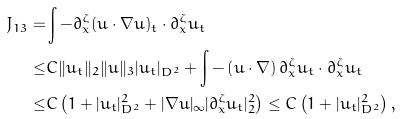Convert formula to latex. <formula><loc_0><loc_0><loc_500><loc_500>J _ { 1 3 } = & \int - \partial ^ { \zeta } _ { x } ( u \cdot \nabla u ) _ { t } \cdot \partial ^ { \zeta } _ { x } u _ { t } \\ \leq & C \| u _ { t } \| _ { 2 } \| u \| _ { 3 } | u _ { t } | _ { D ^ { 2 } } + \int - \left ( u \cdot \nabla \right ) \partial ^ { \zeta } _ { x } u _ { t } \cdot \partial ^ { \zeta } _ { x } u _ { t } \\ \leq & C \left ( 1 + | u _ { t } | ^ { 2 } _ { D ^ { 2 } } + | \nabla u | _ { \infty } | \partial ^ { \zeta } _ { x } u _ { t } | ^ { 2 } _ { 2 } \right ) \leq C \left ( 1 + | u _ { t } | ^ { 2 } _ { D ^ { 2 } } \right ) ,</formula> 